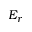Convert formula to latex. <formula><loc_0><loc_0><loc_500><loc_500>E _ { r }</formula> 